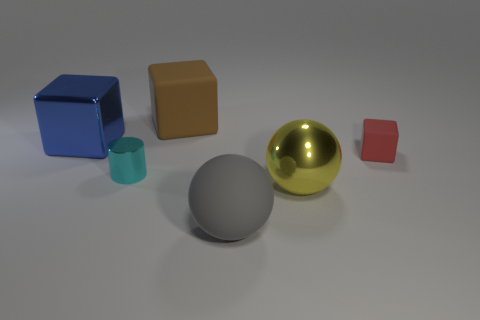How many objects are the same size as the cyan cylinder?
Offer a terse response. 1. How many yellow things are big spheres or tiny shiny things?
Offer a terse response. 1. What is the shape of the large matte thing to the right of the matte thing behind the big blue metallic block?
Offer a very short reply. Sphere. There is a metal thing that is the same size as the red matte cube; what is its shape?
Offer a very short reply. Cylinder. Is the number of big yellow metallic things left of the blue cube the same as the number of objects in front of the big yellow ball?
Give a very brief answer. No. There is a large gray object; does it have the same shape as the big rubber thing behind the metallic cube?
Your answer should be very brief. No. Are there any matte blocks to the left of the tiny rubber block?
Keep it short and to the point. Yes. Does the metal sphere have the same size as the matte thing left of the gray rubber ball?
Your answer should be very brief. Yes. What is the color of the metal thing that is on the right side of the big matte cube behind the gray rubber ball?
Your response must be concise. Yellow. Does the metal cube have the same size as the rubber ball?
Offer a very short reply. Yes. 